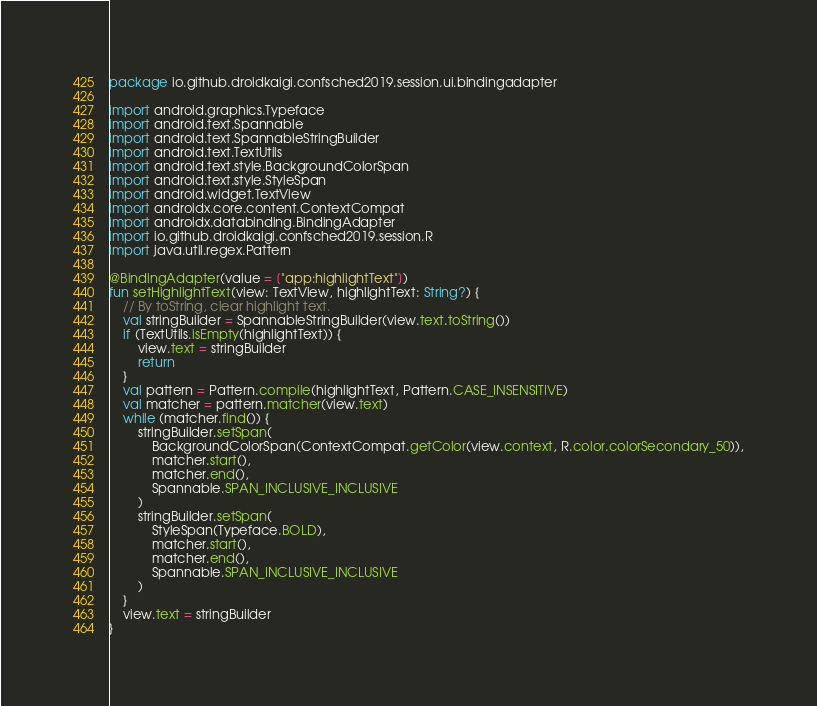Convert code to text. <code><loc_0><loc_0><loc_500><loc_500><_Kotlin_>package io.github.droidkaigi.confsched2019.session.ui.bindingadapter

import android.graphics.Typeface
import android.text.Spannable
import android.text.SpannableStringBuilder
import android.text.TextUtils
import android.text.style.BackgroundColorSpan
import android.text.style.StyleSpan
import android.widget.TextView
import androidx.core.content.ContextCompat
import androidx.databinding.BindingAdapter
import io.github.droidkaigi.confsched2019.session.R
import java.util.regex.Pattern

@BindingAdapter(value = ["app:highlightText"])
fun setHighlightText(view: TextView, highlightText: String?) {
    // By toString, clear highlight text.
    val stringBuilder = SpannableStringBuilder(view.text.toString())
    if (TextUtils.isEmpty(highlightText)) {
        view.text = stringBuilder
        return
    }
    val pattern = Pattern.compile(highlightText, Pattern.CASE_INSENSITIVE)
    val matcher = pattern.matcher(view.text)
    while (matcher.find()) {
        stringBuilder.setSpan(
            BackgroundColorSpan(ContextCompat.getColor(view.context, R.color.colorSecondary_50)),
            matcher.start(),
            matcher.end(),
            Spannable.SPAN_INCLUSIVE_INCLUSIVE
        )
        stringBuilder.setSpan(
            StyleSpan(Typeface.BOLD),
            matcher.start(),
            matcher.end(),
            Spannable.SPAN_INCLUSIVE_INCLUSIVE
        )
    }
    view.text = stringBuilder
}
</code> 